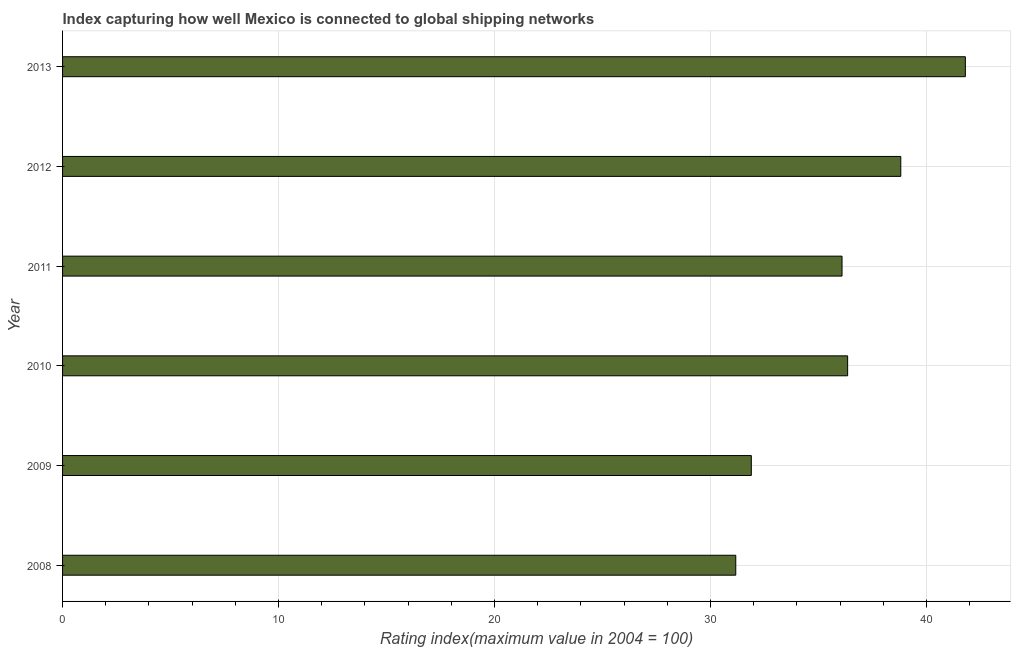What is the title of the graph?
Provide a succinct answer. Index capturing how well Mexico is connected to global shipping networks. What is the label or title of the X-axis?
Keep it short and to the point. Rating index(maximum value in 2004 = 100). What is the liner shipping connectivity index in 2009?
Your answer should be very brief. 31.89. Across all years, what is the maximum liner shipping connectivity index?
Ensure brevity in your answer.  41.8. Across all years, what is the minimum liner shipping connectivity index?
Your answer should be very brief. 31.17. In which year was the liner shipping connectivity index minimum?
Your answer should be compact. 2008. What is the sum of the liner shipping connectivity index?
Keep it short and to the point. 216.11. What is the difference between the liner shipping connectivity index in 2008 and 2013?
Offer a terse response. -10.63. What is the average liner shipping connectivity index per year?
Provide a short and direct response. 36.02. What is the median liner shipping connectivity index?
Your answer should be compact. 36.22. In how many years, is the liner shipping connectivity index greater than 24 ?
Your response must be concise. 6. What is the ratio of the liner shipping connectivity index in 2008 to that in 2011?
Make the answer very short. 0.86. Is the liner shipping connectivity index in 2008 less than that in 2012?
Your answer should be compact. Yes. What is the difference between the highest and the second highest liner shipping connectivity index?
Offer a very short reply. 2.99. Is the sum of the liner shipping connectivity index in 2009 and 2012 greater than the maximum liner shipping connectivity index across all years?
Your answer should be very brief. Yes. What is the difference between the highest and the lowest liner shipping connectivity index?
Your answer should be very brief. 10.63. Are all the bars in the graph horizontal?
Ensure brevity in your answer.  Yes. How many years are there in the graph?
Give a very brief answer. 6. What is the Rating index(maximum value in 2004 = 100) of 2008?
Give a very brief answer. 31.17. What is the Rating index(maximum value in 2004 = 100) of 2009?
Offer a very short reply. 31.89. What is the Rating index(maximum value in 2004 = 100) of 2010?
Ensure brevity in your answer.  36.35. What is the Rating index(maximum value in 2004 = 100) of 2011?
Offer a terse response. 36.09. What is the Rating index(maximum value in 2004 = 100) of 2012?
Your response must be concise. 38.81. What is the Rating index(maximum value in 2004 = 100) in 2013?
Provide a short and direct response. 41.8. What is the difference between the Rating index(maximum value in 2004 = 100) in 2008 and 2009?
Make the answer very short. -0.72. What is the difference between the Rating index(maximum value in 2004 = 100) in 2008 and 2010?
Keep it short and to the point. -5.18. What is the difference between the Rating index(maximum value in 2004 = 100) in 2008 and 2011?
Provide a succinct answer. -4.92. What is the difference between the Rating index(maximum value in 2004 = 100) in 2008 and 2012?
Provide a succinct answer. -7.64. What is the difference between the Rating index(maximum value in 2004 = 100) in 2008 and 2013?
Make the answer very short. -10.63. What is the difference between the Rating index(maximum value in 2004 = 100) in 2009 and 2010?
Provide a succinct answer. -4.46. What is the difference between the Rating index(maximum value in 2004 = 100) in 2009 and 2011?
Keep it short and to the point. -4.2. What is the difference between the Rating index(maximum value in 2004 = 100) in 2009 and 2012?
Your answer should be compact. -6.92. What is the difference between the Rating index(maximum value in 2004 = 100) in 2009 and 2013?
Keep it short and to the point. -9.91. What is the difference between the Rating index(maximum value in 2004 = 100) in 2010 and 2011?
Offer a very short reply. 0.26. What is the difference between the Rating index(maximum value in 2004 = 100) in 2010 and 2012?
Your answer should be very brief. -2.46. What is the difference between the Rating index(maximum value in 2004 = 100) in 2010 and 2013?
Your answer should be very brief. -5.45. What is the difference between the Rating index(maximum value in 2004 = 100) in 2011 and 2012?
Give a very brief answer. -2.72. What is the difference between the Rating index(maximum value in 2004 = 100) in 2011 and 2013?
Provide a succinct answer. -5.71. What is the difference between the Rating index(maximum value in 2004 = 100) in 2012 and 2013?
Your answer should be very brief. -2.99. What is the ratio of the Rating index(maximum value in 2004 = 100) in 2008 to that in 2009?
Your answer should be compact. 0.98. What is the ratio of the Rating index(maximum value in 2004 = 100) in 2008 to that in 2010?
Offer a very short reply. 0.86. What is the ratio of the Rating index(maximum value in 2004 = 100) in 2008 to that in 2011?
Make the answer very short. 0.86. What is the ratio of the Rating index(maximum value in 2004 = 100) in 2008 to that in 2012?
Offer a very short reply. 0.8. What is the ratio of the Rating index(maximum value in 2004 = 100) in 2008 to that in 2013?
Provide a short and direct response. 0.75. What is the ratio of the Rating index(maximum value in 2004 = 100) in 2009 to that in 2010?
Ensure brevity in your answer.  0.88. What is the ratio of the Rating index(maximum value in 2004 = 100) in 2009 to that in 2011?
Make the answer very short. 0.88. What is the ratio of the Rating index(maximum value in 2004 = 100) in 2009 to that in 2012?
Offer a very short reply. 0.82. What is the ratio of the Rating index(maximum value in 2004 = 100) in 2009 to that in 2013?
Your answer should be very brief. 0.76. What is the ratio of the Rating index(maximum value in 2004 = 100) in 2010 to that in 2012?
Your answer should be very brief. 0.94. What is the ratio of the Rating index(maximum value in 2004 = 100) in 2010 to that in 2013?
Offer a very short reply. 0.87. What is the ratio of the Rating index(maximum value in 2004 = 100) in 2011 to that in 2013?
Your answer should be very brief. 0.86. What is the ratio of the Rating index(maximum value in 2004 = 100) in 2012 to that in 2013?
Ensure brevity in your answer.  0.93. 